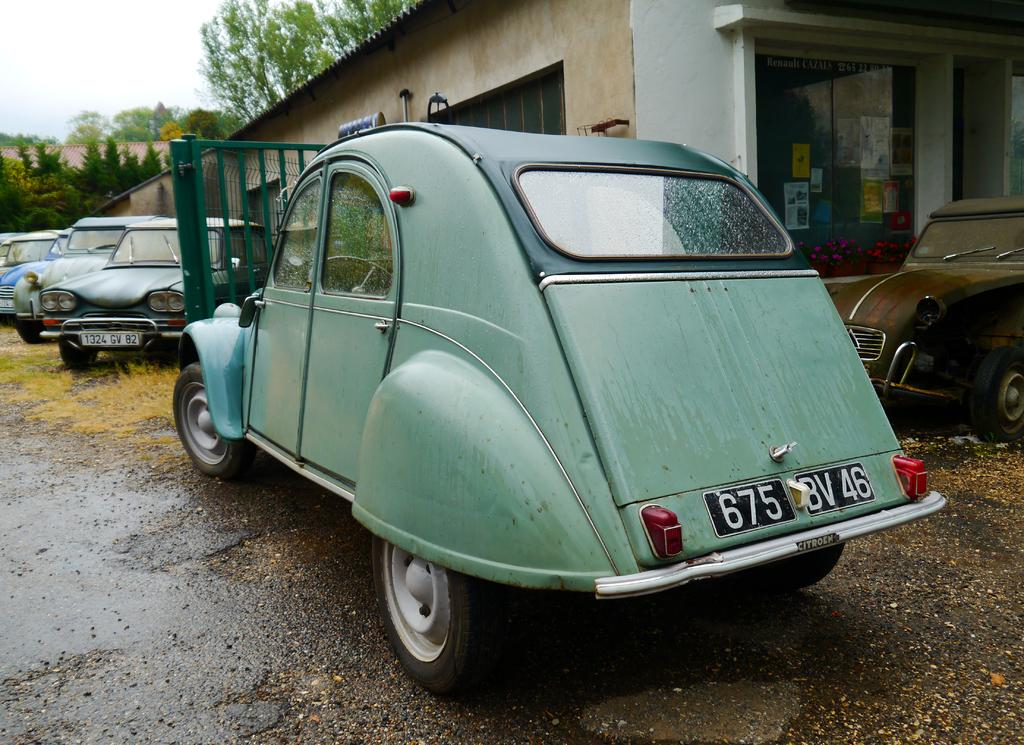What can be seen on the ground in the image? There are vehicles parked on the ground in the image. What type of barrier is present in the image? There is a metal fence in the image. What is visible in the background of the image? There is a building with a group of windows and a group of trees in the background of the image. What part of the natural environment is visible in the image? The sky is visible in the background of the image. What type of acoustics can be heard in the image? There is no information about sounds or acoustics in the image, so it cannot be determined. Can you see a quill being used to write on a hall in the image? There is no reference to a quill, writing, or a hall in the image. 